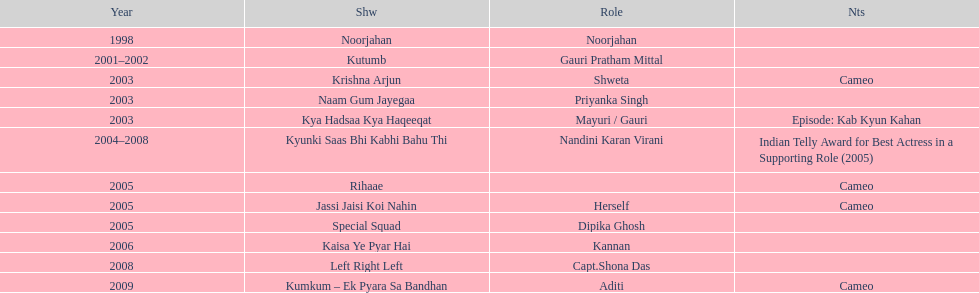What was the most years a show lasted? 4. 